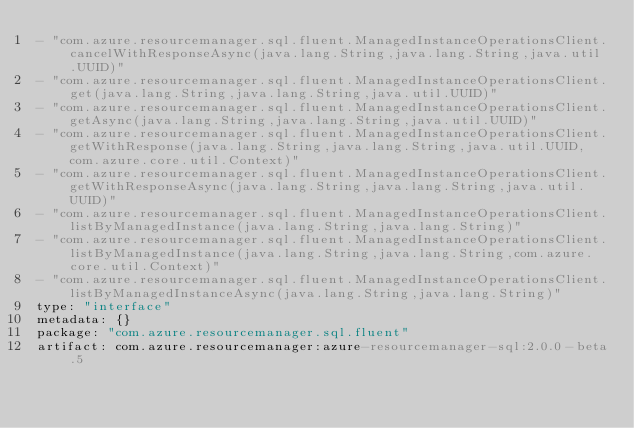<code> <loc_0><loc_0><loc_500><loc_500><_YAML_>- "com.azure.resourcemanager.sql.fluent.ManagedInstanceOperationsClient.cancelWithResponseAsync(java.lang.String,java.lang.String,java.util.UUID)"
- "com.azure.resourcemanager.sql.fluent.ManagedInstanceOperationsClient.get(java.lang.String,java.lang.String,java.util.UUID)"
- "com.azure.resourcemanager.sql.fluent.ManagedInstanceOperationsClient.getAsync(java.lang.String,java.lang.String,java.util.UUID)"
- "com.azure.resourcemanager.sql.fluent.ManagedInstanceOperationsClient.getWithResponse(java.lang.String,java.lang.String,java.util.UUID,com.azure.core.util.Context)"
- "com.azure.resourcemanager.sql.fluent.ManagedInstanceOperationsClient.getWithResponseAsync(java.lang.String,java.lang.String,java.util.UUID)"
- "com.azure.resourcemanager.sql.fluent.ManagedInstanceOperationsClient.listByManagedInstance(java.lang.String,java.lang.String)"
- "com.azure.resourcemanager.sql.fluent.ManagedInstanceOperationsClient.listByManagedInstance(java.lang.String,java.lang.String,com.azure.core.util.Context)"
- "com.azure.resourcemanager.sql.fluent.ManagedInstanceOperationsClient.listByManagedInstanceAsync(java.lang.String,java.lang.String)"
type: "interface"
metadata: {}
package: "com.azure.resourcemanager.sql.fluent"
artifact: com.azure.resourcemanager:azure-resourcemanager-sql:2.0.0-beta.5
</code> 